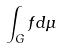Convert formula to latex. <formula><loc_0><loc_0><loc_500><loc_500>\int _ { G } f d \mu</formula> 